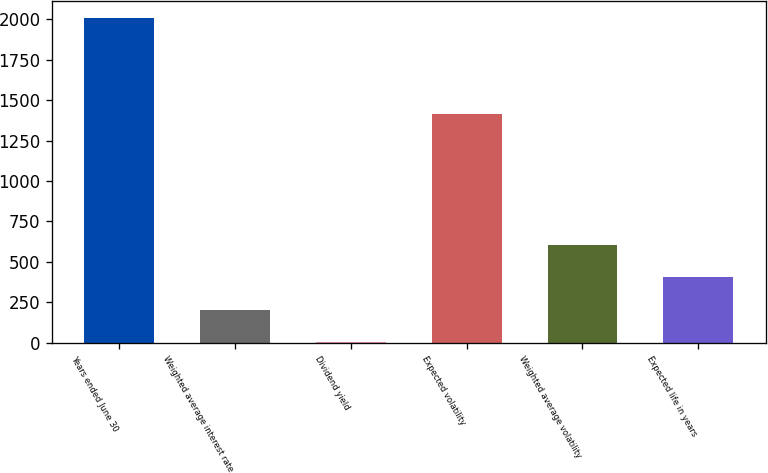Convert chart. <chart><loc_0><loc_0><loc_500><loc_500><bar_chart><fcel>Years ended June 30<fcel>Weighted average interest rate<fcel>Dividend yield<fcel>Expected volatility<fcel>Weighted average volatility<fcel>Expected life in years<nl><fcel>2011<fcel>203.26<fcel>2.4<fcel>1418<fcel>604.98<fcel>404.12<nl></chart> 